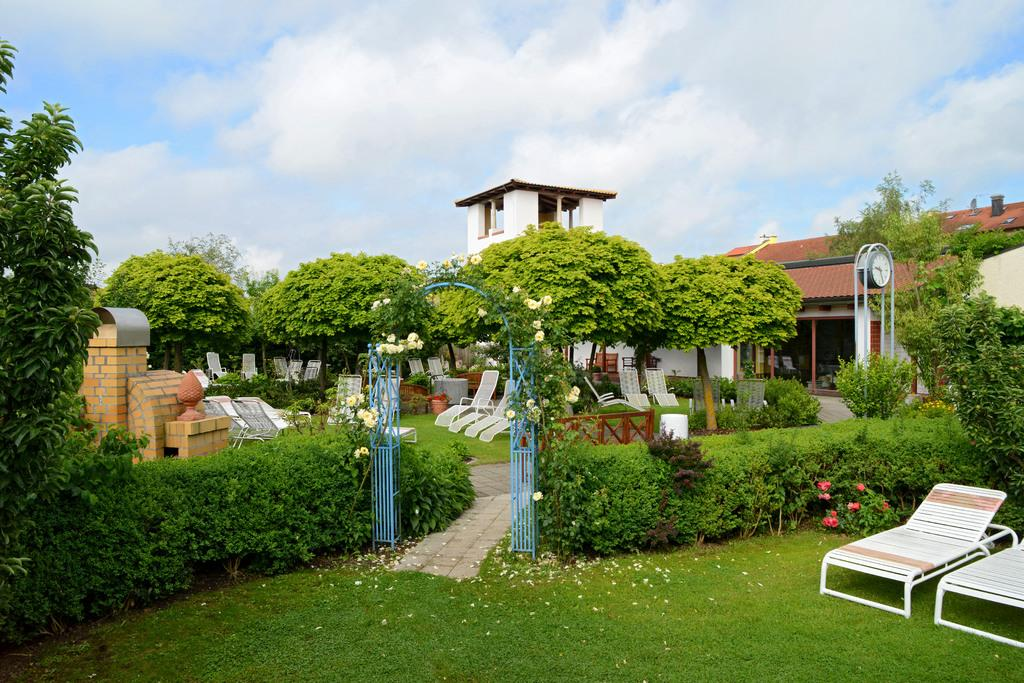What type of furniture can be seen on the ground in the image? There are chairs on the ground in the image. What type of vegetation is present in the image? There are plants, flowers, and trees in the image. What type of structure can be seen in the image? There is an arch, a fence, houses, a building, and a clock in the image. What is visible in the background of the image? The sky is visible in the background of the image. What other objects can be seen in the image? There are some objects in the image. Where is the pencil located in the image? There is no pencil present in the image. What type of notebook is being used by the flowers in the image? There are no notebooks present in the image, as flowers are not capable of using notebooks. 